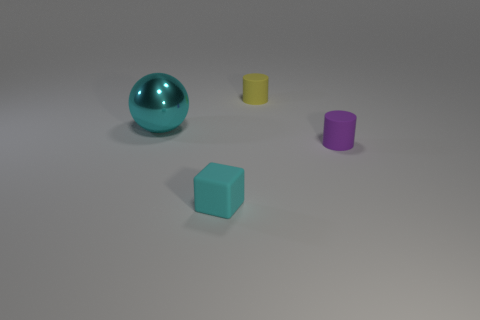There is a metallic object; does it have the same color as the rubber thing in front of the tiny purple matte cylinder?
Make the answer very short. Yes. What size is the matte object that is in front of the large cyan metallic object and to the right of the cube?
Offer a very short reply. Small. There is a yellow cylinder; are there any tiny cylinders in front of it?
Provide a short and direct response. Yes. There is a cylinder behind the cyan shiny sphere; are there any small cubes that are left of it?
Make the answer very short. Yes. Is the number of large cyan objects that are to the left of the large cyan object the same as the number of tiny purple matte cylinders behind the small cyan rubber block?
Ensure brevity in your answer.  No. What color is the other cylinder that is made of the same material as the yellow cylinder?
Offer a terse response. Purple. Are there any big cyan things that have the same material as the tiny purple cylinder?
Provide a succinct answer. No. What number of things are big cyan spheres or green cylinders?
Provide a short and direct response. 1. Do the tiny cyan cube and the cylinder that is on the right side of the yellow matte cylinder have the same material?
Offer a very short reply. Yes. What size is the cyan shiny object that is in front of the yellow cylinder?
Ensure brevity in your answer.  Large. 